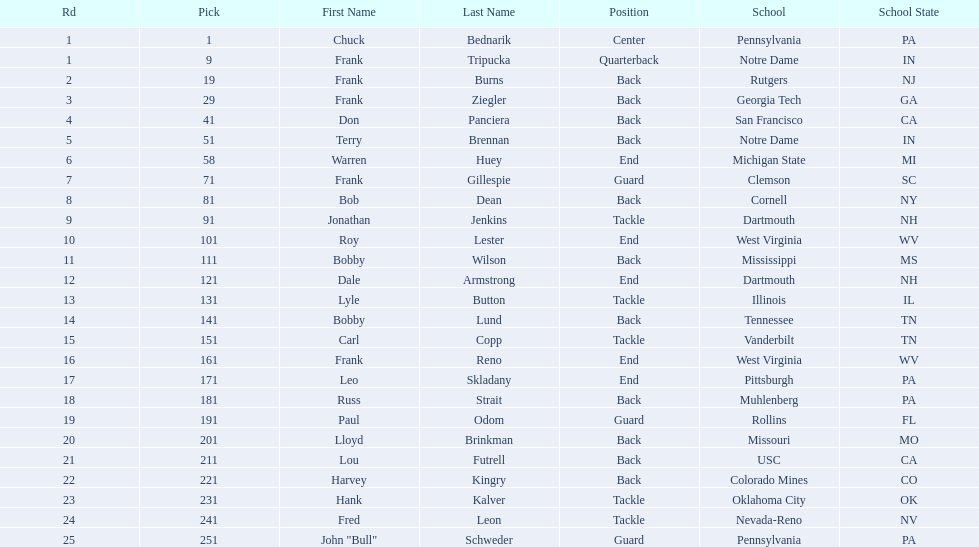Was chuck bednarik or frank tripucka the first draft pick? Chuck Bednarik. 